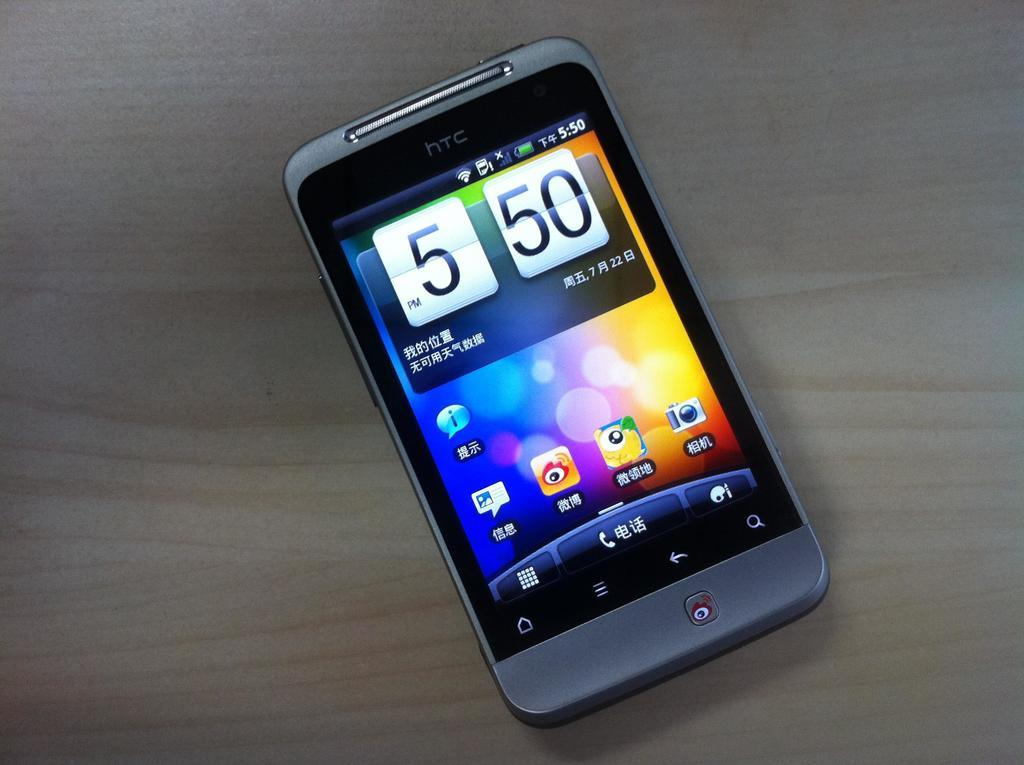<image>
Write a terse but informative summary of the picture. The time displayed on this cell phone's screen is 5:50 pm. 